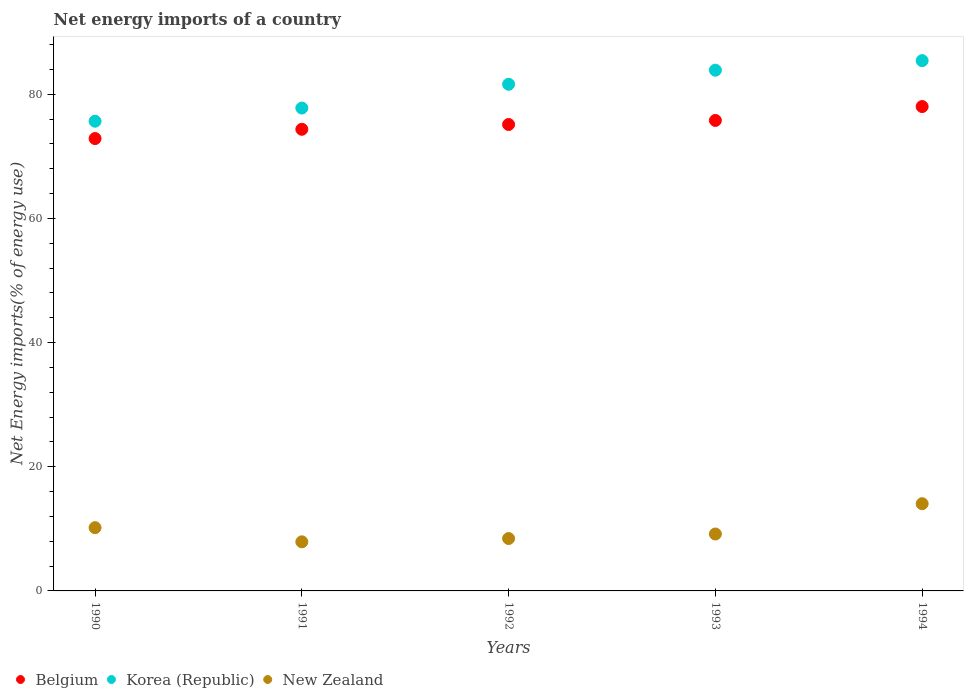Is the number of dotlines equal to the number of legend labels?
Offer a very short reply. Yes. What is the net energy imports in Belgium in 1990?
Provide a short and direct response. 72.86. Across all years, what is the maximum net energy imports in Korea (Republic)?
Your response must be concise. 85.41. Across all years, what is the minimum net energy imports in Belgium?
Provide a short and direct response. 72.86. What is the total net energy imports in Korea (Republic) in the graph?
Your answer should be compact. 404.31. What is the difference between the net energy imports in Korea (Republic) in 1991 and that in 1994?
Provide a short and direct response. -7.64. What is the difference between the net energy imports in Korea (Republic) in 1993 and the net energy imports in New Zealand in 1994?
Provide a short and direct response. 69.82. What is the average net energy imports in Korea (Republic) per year?
Your response must be concise. 80.86. In the year 1993, what is the difference between the net energy imports in New Zealand and net energy imports in Belgium?
Provide a short and direct response. -66.61. What is the ratio of the net energy imports in New Zealand in 1991 to that in 1994?
Ensure brevity in your answer.  0.56. Is the difference between the net energy imports in New Zealand in 1990 and 1993 greater than the difference between the net energy imports in Belgium in 1990 and 1993?
Ensure brevity in your answer.  Yes. What is the difference between the highest and the second highest net energy imports in Korea (Republic)?
Your answer should be very brief. 1.54. What is the difference between the highest and the lowest net energy imports in Belgium?
Offer a terse response. 5.15. Is it the case that in every year, the sum of the net energy imports in New Zealand and net energy imports in Korea (Republic)  is greater than the net energy imports in Belgium?
Ensure brevity in your answer.  Yes. Does the net energy imports in Korea (Republic) monotonically increase over the years?
Make the answer very short. Yes. Is the net energy imports in Korea (Republic) strictly greater than the net energy imports in New Zealand over the years?
Your response must be concise. Yes. Is the net energy imports in Korea (Republic) strictly less than the net energy imports in Belgium over the years?
Offer a very short reply. No. How many dotlines are there?
Offer a very short reply. 3. What is the difference between two consecutive major ticks on the Y-axis?
Give a very brief answer. 20. Are the values on the major ticks of Y-axis written in scientific E-notation?
Your response must be concise. No. Does the graph contain grids?
Keep it short and to the point. No. Where does the legend appear in the graph?
Your answer should be very brief. Bottom left. How many legend labels are there?
Make the answer very short. 3. What is the title of the graph?
Your answer should be very brief. Net energy imports of a country. Does "Central Europe" appear as one of the legend labels in the graph?
Provide a short and direct response. No. What is the label or title of the X-axis?
Provide a short and direct response. Years. What is the label or title of the Y-axis?
Your answer should be compact. Net Energy imports(% of energy use). What is the Net Energy imports(% of energy use) in Belgium in 1990?
Your answer should be compact. 72.86. What is the Net Energy imports(% of energy use) in Korea (Republic) in 1990?
Give a very brief answer. 75.65. What is the Net Energy imports(% of energy use) in New Zealand in 1990?
Your response must be concise. 10.19. What is the Net Energy imports(% of energy use) of Belgium in 1991?
Give a very brief answer. 74.35. What is the Net Energy imports(% of energy use) of Korea (Republic) in 1991?
Your answer should be compact. 77.77. What is the Net Energy imports(% of energy use) in New Zealand in 1991?
Provide a short and direct response. 7.91. What is the Net Energy imports(% of energy use) in Belgium in 1992?
Your response must be concise. 75.13. What is the Net Energy imports(% of energy use) in Korea (Republic) in 1992?
Offer a terse response. 81.61. What is the Net Energy imports(% of energy use) in New Zealand in 1992?
Ensure brevity in your answer.  8.44. What is the Net Energy imports(% of energy use) of Belgium in 1993?
Your response must be concise. 75.78. What is the Net Energy imports(% of energy use) of Korea (Republic) in 1993?
Offer a terse response. 83.87. What is the Net Energy imports(% of energy use) of New Zealand in 1993?
Make the answer very short. 9.17. What is the Net Energy imports(% of energy use) in Belgium in 1994?
Offer a terse response. 78.01. What is the Net Energy imports(% of energy use) in Korea (Republic) in 1994?
Keep it short and to the point. 85.41. What is the Net Energy imports(% of energy use) of New Zealand in 1994?
Your answer should be compact. 14.05. Across all years, what is the maximum Net Energy imports(% of energy use) in Belgium?
Keep it short and to the point. 78.01. Across all years, what is the maximum Net Energy imports(% of energy use) of Korea (Republic)?
Your response must be concise. 85.41. Across all years, what is the maximum Net Energy imports(% of energy use) in New Zealand?
Ensure brevity in your answer.  14.05. Across all years, what is the minimum Net Energy imports(% of energy use) in Belgium?
Give a very brief answer. 72.86. Across all years, what is the minimum Net Energy imports(% of energy use) in Korea (Republic)?
Provide a succinct answer. 75.65. Across all years, what is the minimum Net Energy imports(% of energy use) in New Zealand?
Your response must be concise. 7.91. What is the total Net Energy imports(% of energy use) of Belgium in the graph?
Offer a terse response. 376.13. What is the total Net Energy imports(% of energy use) of Korea (Republic) in the graph?
Make the answer very short. 404.31. What is the total Net Energy imports(% of energy use) in New Zealand in the graph?
Provide a short and direct response. 49.75. What is the difference between the Net Energy imports(% of energy use) in Belgium in 1990 and that in 1991?
Keep it short and to the point. -1.49. What is the difference between the Net Energy imports(% of energy use) in Korea (Republic) in 1990 and that in 1991?
Make the answer very short. -2.12. What is the difference between the Net Energy imports(% of energy use) of New Zealand in 1990 and that in 1991?
Give a very brief answer. 2.28. What is the difference between the Net Energy imports(% of energy use) of Belgium in 1990 and that in 1992?
Your answer should be very brief. -2.27. What is the difference between the Net Energy imports(% of energy use) in Korea (Republic) in 1990 and that in 1992?
Ensure brevity in your answer.  -5.95. What is the difference between the Net Energy imports(% of energy use) in Belgium in 1990 and that in 1993?
Make the answer very short. -2.92. What is the difference between the Net Energy imports(% of energy use) of Korea (Republic) in 1990 and that in 1993?
Give a very brief answer. -8.22. What is the difference between the Net Energy imports(% of energy use) of New Zealand in 1990 and that in 1993?
Your answer should be compact. 1.02. What is the difference between the Net Energy imports(% of energy use) of Belgium in 1990 and that in 1994?
Make the answer very short. -5.15. What is the difference between the Net Energy imports(% of energy use) of Korea (Republic) in 1990 and that in 1994?
Provide a short and direct response. -9.76. What is the difference between the Net Energy imports(% of energy use) in New Zealand in 1990 and that in 1994?
Offer a terse response. -3.86. What is the difference between the Net Energy imports(% of energy use) of Belgium in 1991 and that in 1992?
Offer a terse response. -0.77. What is the difference between the Net Energy imports(% of energy use) of Korea (Republic) in 1991 and that in 1992?
Keep it short and to the point. -3.83. What is the difference between the Net Energy imports(% of energy use) of New Zealand in 1991 and that in 1992?
Keep it short and to the point. -0.53. What is the difference between the Net Energy imports(% of energy use) in Belgium in 1991 and that in 1993?
Your response must be concise. -1.43. What is the difference between the Net Energy imports(% of energy use) of Korea (Republic) in 1991 and that in 1993?
Give a very brief answer. -6.1. What is the difference between the Net Energy imports(% of energy use) of New Zealand in 1991 and that in 1993?
Offer a very short reply. -1.26. What is the difference between the Net Energy imports(% of energy use) of Belgium in 1991 and that in 1994?
Give a very brief answer. -3.66. What is the difference between the Net Energy imports(% of energy use) of Korea (Republic) in 1991 and that in 1994?
Your answer should be very brief. -7.64. What is the difference between the Net Energy imports(% of energy use) in New Zealand in 1991 and that in 1994?
Your answer should be compact. -6.14. What is the difference between the Net Energy imports(% of energy use) in Belgium in 1992 and that in 1993?
Offer a very short reply. -0.65. What is the difference between the Net Energy imports(% of energy use) in Korea (Republic) in 1992 and that in 1993?
Give a very brief answer. -2.26. What is the difference between the Net Energy imports(% of energy use) of New Zealand in 1992 and that in 1993?
Ensure brevity in your answer.  -0.73. What is the difference between the Net Energy imports(% of energy use) in Belgium in 1992 and that in 1994?
Give a very brief answer. -2.89. What is the difference between the Net Energy imports(% of energy use) of Korea (Republic) in 1992 and that in 1994?
Provide a short and direct response. -3.8. What is the difference between the Net Energy imports(% of energy use) in New Zealand in 1992 and that in 1994?
Your response must be concise. -5.61. What is the difference between the Net Energy imports(% of energy use) in Belgium in 1993 and that in 1994?
Make the answer very short. -2.24. What is the difference between the Net Energy imports(% of energy use) of Korea (Republic) in 1993 and that in 1994?
Make the answer very short. -1.54. What is the difference between the Net Energy imports(% of energy use) in New Zealand in 1993 and that in 1994?
Offer a very short reply. -4.88. What is the difference between the Net Energy imports(% of energy use) of Belgium in 1990 and the Net Energy imports(% of energy use) of Korea (Republic) in 1991?
Your answer should be very brief. -4.91. What is the difference between the Net Energy imports(% of energy use) of Belgium in 1990 and the Net Energy imports(% of energy use) of New Zealand in 1991?
Give a very brief answer. 64.95. What is the difference between the Net Energy imports(% of energy use) of Korea (Republic) in 1990 and the Net Energy imports(% of energy use) of New Zealand in 1991?
Your response must be concise. 67.74. What is the difference between the Net Energy imports(% of energy use) in Belgium in 1990 and the Net Energy imports(% of energy use) in Korea (Republic) in 1992?
Offer a terse response. -8.75. What is the difference between the Net Energy imports(% of energy use) of Belgium in 1990 and the Net Energy imports(% of energy use) of New Zealand in 1992?
Provide a short and direct response. 64.42. What is the difference between the Net Energy imports(% of energy use) of Korea (Republic) in 1990 and the Net Energy imports(% of energy use) of New Zealand in 1992?
Ensure brevity in your answer.  67.21. What is the difference between the Net Energy imports(% of energy use) in Belgium in 1990 and the Net Energy imports(% of energy use) in Korea (Republic) in 1993?
Your response must be concise. -11.01. What is the difference between the Net Energy imports(% of energy use) in Belgium in 1990 and the Net Energy imports(% of energy use) in New Zealand in 1993?
Offer a very short reply. 63.69. What is the difference between the Net Energy imports(% of energy use) in Korea (Republic) in 1990 and the Net Energy imports(% of energy use) in New Zealand in 1993?
Keep it short and to the point. 66.48. What is the difference between the Net Energy imports(% of energy use) in Belgium in 1990 and the Net Energy imports(% of energy use) in Korea (Republic) in 1994?
Provide a short and direct response. -12.55. What is the difference between the Net Energy imports(% of energy use) of Belgium in 1990 and the Net Energy imports(% of energy use) of New Zealand in 1994?
Offer a terse response. 58.81. What is the difference between the Net Energy imports(% of energy use) of Korea (Republic) in 1990 and the Net Energy imports(% of energy use) of New Zealand in 1994?
Offer a terse response. 61.6. What is the difference between the Net Energy imports(% of energy use) of Belgium in 1991 and the Net Energy imports(% of energy use) of Korea (Republic) in 1992?
Offer a very short reply. -7.25. What is the difference between the Net Energy imports(% of energy use) of Belgium in 1991 and the Net Energy imports(% of energy use) of New Zealand in 1992?
Your answer should be compact. 65.91. What is the difference between the Net Energy imports(% of energy use) of Korea (Republic) in 1991 and the Net Energy imports(% of energy use) of New Zealand in 1992?
Provide a succinct answer. 69.34. What is the difference between the Net Energy imports(% of energy use) in Belgium in 1991 and the Net Energy imports(% of energy use) in Korea (Republic) in 1993?
Provide a short and direct response. -9.52. What is the difference between the Net Energy imports(% of energy use) in Belgium in 1991 and the Net Energy imports(% of energy use) in New Zealand in 1993?
Ensure brevity in your answer.  65.18. What is the difference between the Net Energy imports(% of energy use) in Korea (Republic) in 1991 and the Net Energy imports(% of energy use) in New Zealand in 1993?
Provide a succinct answer. 68.61. What is the difference between the Net Energy imports(% of energy use) of Belgium in 1991 and the Net Energy imports(% of energy use) of Korea (Republic) in 1994?
Your answer should be compact. -11.06. What is the difference between the Net Energy imports(% of energy use) of Belgium in 1991 and the Net Energy imports(% of energy use) of New Zealand in 1994?
Your answer should be very brief. 60.3. What is the difference between the Net Energy imports(% of energy use) in Korea (Republic) in 1991 and the Net Energy imports(% of energy use) in New Zealand in 1994?
Give a very brief answer. 63.73. What is the difference between the Net Energy imports(% of energy use) of Belgium in 1992 and the Net Energy imports(% of energy use) of Korea (Republic) in 1993?
Ensure brevity in your answer.  -8.74. What is the difference between the Net Energy imports(% of energy use) in Belgium in 1992 and the Net Energy imports(% of energy use) in New Zealand in 1993?
Make the answer very short. 65.96. What is the difference between the Net Energy imports(% of energy use) of Korea (Republic) in 1992 and the Net Energy imports(% of energy use) of New Zealand in 1993?
Keep it short and to the point. 72.44. What is the difference between the Net Energy imports(% of energy use) of Belgium in 1992 and the Net Energy imports(% of energy use) of Korea (Republic) in 1994?
Give a very brief answer. -10.28. What is the difference between the Net Energy imports(% of energy use) in Belgium in 1992 and the Net Energy imports(% of energy use) in New Zealand in 1994?
Give a very brief answer. 61.08. What is the difference between the Net Energy imports(% of energy use) of Korea (Republic) in 1992 and the Net Energy imports(% of energy use) of New Zealand in 1994?
Make the answer very short. 67.56. What is the difference between the Net Energy imports(% of energy use) of Belgium in 1993 and the Net Energy imports(% of energy use) of Korea (Republic) in 1994?
Keep it short and to the point. -9.63. What is the difference between the Net Energy imports(% of energy use) of Belgium in 1993 and the Net Energy imports(% of energy use) of New Zealand in 1994?
Your response must be concise. 61.73. What is the difference between the Net Energy imports(% of energy use) in Korea (Republic) in 1993 and the Net Energy imports(% of energy use) in New Zealand in 1994?
Your response must be concise. 69.82. What is the average Net Energy imports(% of energy use) in Belgium per year?
Ensure brevity in your answer.  75.23. What is the average Net Energy imports(% of energy use) in Korea (Republic) per year?
Offer a terse response. 80.86. What is the average Net Energy imports(% of energy use) of New Zealand per year?
Your answer should be compact. 9.95. In the year 1990, what is the difference between the Net Energy imports(% of energy use) in Belgium and Net Energy imports(% of energy use) in Korea (Republic)?
Provide a succinct answer. -2.79. In the year 1990, what is the difference between the Net Energy imports(% of energy use) of Belgium and Net Energy imports(% of energy use) of New Zealand?
Provide a succinct answer. 62.67. In the year 1990, what is the difference between the Net Energy imports(% of energy use) of Korea (Republic) and Net Energy imports(% of energy use) of New Zealand?
Make the answer very short. 65.46. In the year 1991, what is the difference between the Net Energy imports(% of energy use) of Belgium and Net Energy imports(% of energy use) of Korea (Republic)?
Offer a terse response. -3.42. In the year 1991, what is the difference between the Net Energy imports(% of energy use) of Belgium and Net Energy imports(% of energy use) of New Zealand?
Provide a short and direct response. 66.44. In the year 1991, what is the difference between the Net Energy imports(% of energy use) of Korea (Republic) and Net Energy imports(% of energy use) of New Zealand?
Provide a short and direct response. 69.87. In the year 1992, what is the difference between the Net Energy imports(% of energy use) of Belgium and Net Energy imports(% of energy use) of Korea (Republic)?
Ensure brevity in your answer.  -6.48. In the year 1992, what is the difference between the Net Energy imports(% of energy use) of Belgium and Net Energy imports(% of energy use) of New Zealand?
Keep it short and to the point. 66.69. In the year 1992, what is the difference between the Net Energy imports(% of energy use) in Korea (Republic) and Net Energy imports(% of energy use) in New Zealand?
Ensure brevity in your answer.  73.17. In the year 1993, what is the difference between the Net Energy imports(% of energy use) of Belgium and Net Energy imports(% of energy use) of Korea (Republic)?
Give a very brief answer. -8.09. In the year 1993, what is the difference between the Net Energy imports(% of energy use) of Belgium and Net Energy imports(% of energy use) of New Zealand?
Offer a terse response. 66.61. In the year 1993, what is the difference between the Net Energy imports(% of energy use) of Korea (Republic) and Net Energy imports(% of energy use) of New Zealand?
Ensure brevity in your answer.  74.7. In the year 1994, what is the difference between the Net Energy imports(% of energy use) in Belgium and Net Energy imports(% of energy use) in Korea (Republic)?
Your answer should be compact. -7.4. In the year 1994, what is the difference between the Net Energy imports(% of energy use) of Belgium and Net Energy imports(% of energy use) of New Zealand?
Make the answer very short. 63.97. In the year 1994, what is the difference between the Net Energy imports(% of energy use) of Korea (Republic) and Net Energy imports(% of energy use) of New Zealand?
Ensure brevity in your answer.  71.36. What is the ratio of the Net Energy imports(% of energy use) of Belgium in 1990 to that in 1991?
Your answer should be compact. 0.98. What is the ratio of the Net Energy imports(% of energy use) in Korea (Republic) in 1990 to that in 1991?
Offer a terse response. 0.97. What is the ratio of the Net Energy imports(% of energy use) of New Zealand in 1990 to that in 1991?
Keep it short and to the point. 1.29. What is the ratio of the Net Energy imports(% of energy use) in Belgium in 1990 to that in 1992?
Offer a terse response. 0.97. What is the ratio of the Net Energy imports(% of energy use) of Korea (Republic) in 1990 to that in 1992?
Your answer should be very brief. 0.93. What is the ratio of the Net Energy imports(% of energy use) of New Zealand in 1990 to that in 1992?
Keep it short and to the point. 1.21. What is the ratio of the Net Energy imports(% of energy use) in Belgium in 1990 to that in 1993?
Keep it short and to the point. 0.96. What is the ratio of the Net Energy imports(% of energy use) in Korea (Republic) in 1990 to that in 1993?
Offer a terse response. 0.9. What is the ratio of the Net Energy imports(% of energy use) in New Zealand in 1990 to that in 1993?
Keep it short and to the point. 1.11. What is the ratio of the Net Energy imports(% of energy use) of Belgium in 1990 to that in 1994?
Your answer should be compact. 0.93. What is the ratio of the Net Energy imports(% of energy use) in Korea (Republic) in 1990 to that in 1994?
Keep it short and to the point. 0.89. What is the ratio of the Net Energy imports(% of energy use) of New Zealand in 1990 to that in 1994?
Your response must be concise. 0.73. What is the ratio of the Net Energy imports(% of energy use) in Belgium in 1991 to that in 1992?
Your answer should be very brief. 0.99. What is the ratio of the Net Energy imports(% of energy use) in Korea (Republic) in 1991 to that in 1992?
Keep it short and to the point. 0.95. What is the ratio of the Net Energy imports(% of energy use) in New Zealand in 1991 to that in 1992?
Your answer should be very brief. 0.94. What is the ratio of the Net Energy imports(% of energy use) of Belgium in 1991 to that in 1993?
Your answer should be compact. 0.98. What is the ratio of the Net Energy imports(% of energy use) in Korea (Republic) in 1991 to that in 1993?
Your answer should be very brief. 0.93. What is the ratio of the Net Energy imports(% of energy use) of New Zealand in 1991 to that in 1993?
Provide a succinct answer. 0.86. What is the ratio of the Net Energy imports(% of energy use) in Belgium in 1991 to that in 1994?
Offer a very short reply. 0.95. What is the ratio of the Net Energy imports(% of energy use) of Korea (Republic) in 1991 to that in 1994?
Give a very brief answer. 0.91. What is the ratio of the Net Energy imports(% of energy use) of New Zealand in 1991 to that in 1994?
Provide a short and direct response. 0.56. What is the ratio of the Net Energy imports(% of energy use) of Belgium in 1992 to that in 1993?
Offer a very short reply. 0.99. What is the ratio of the Net Energy imports(% of energy use) in Korea (Republic) in 1992 to that in 1993?
Your answer should be very brief. 0.97. What is the ratio of the Net Energy imports(% of energy use) in New Zealand in 1992 to that in 1993?
Keep it short and to the point. 0.92. What is the ratio of the Net Energy imports(% of energy use) of Belgium in 1992 to that in 1994?
Provide a succinct answer. 0.96. What is the ratio of the Net Energy imports(% of energy use) in Korea (Republic) in 1992 to that in 1994?
Offer a terse response. 0.96. What is the ratio of the Net Energy imports(% of energy use) of New Zealand in 1992 to that in 1994?
Offer a terse response. 0.6. What is the ratio of the Net Energy imports(% of energy use) in Belgium in 1993 to that in 1994?
Keep it short and to the point. 0.97. What is the ratio of the Net Energy imports(% of energy use) in New Zealand in 1993 to that in 1994?
Your response must be concise. 0.65. What is the difference between the highest and the second highest Net Energy imports(% of energy use) in Belgium?
Your answer should be compact. 2.24. What is the difference between the highest and the second highest Net Energy imports(% of energy use) of Korea (Republic)?
Your response must be concise. 1.54. What is the difference between the highest and the second highest Net Energy imports(% of energy use) in New Zealand?
Your answer should be very brief. 3.86. What is the difference between the highest and the lowest Net Energy imports(% of energy use) in Belgium?
Offer a very short reply. 5.15. What is the difference between the highest and the lowest Net Energy imports(% of energy use) of Korea (Republic)?
Provide a succinct answer. 9.76. What is the difference between the highest and the lowest Net Energy imports(% of energy use) of New Zealand?
Make the answer very short. 6.14. 